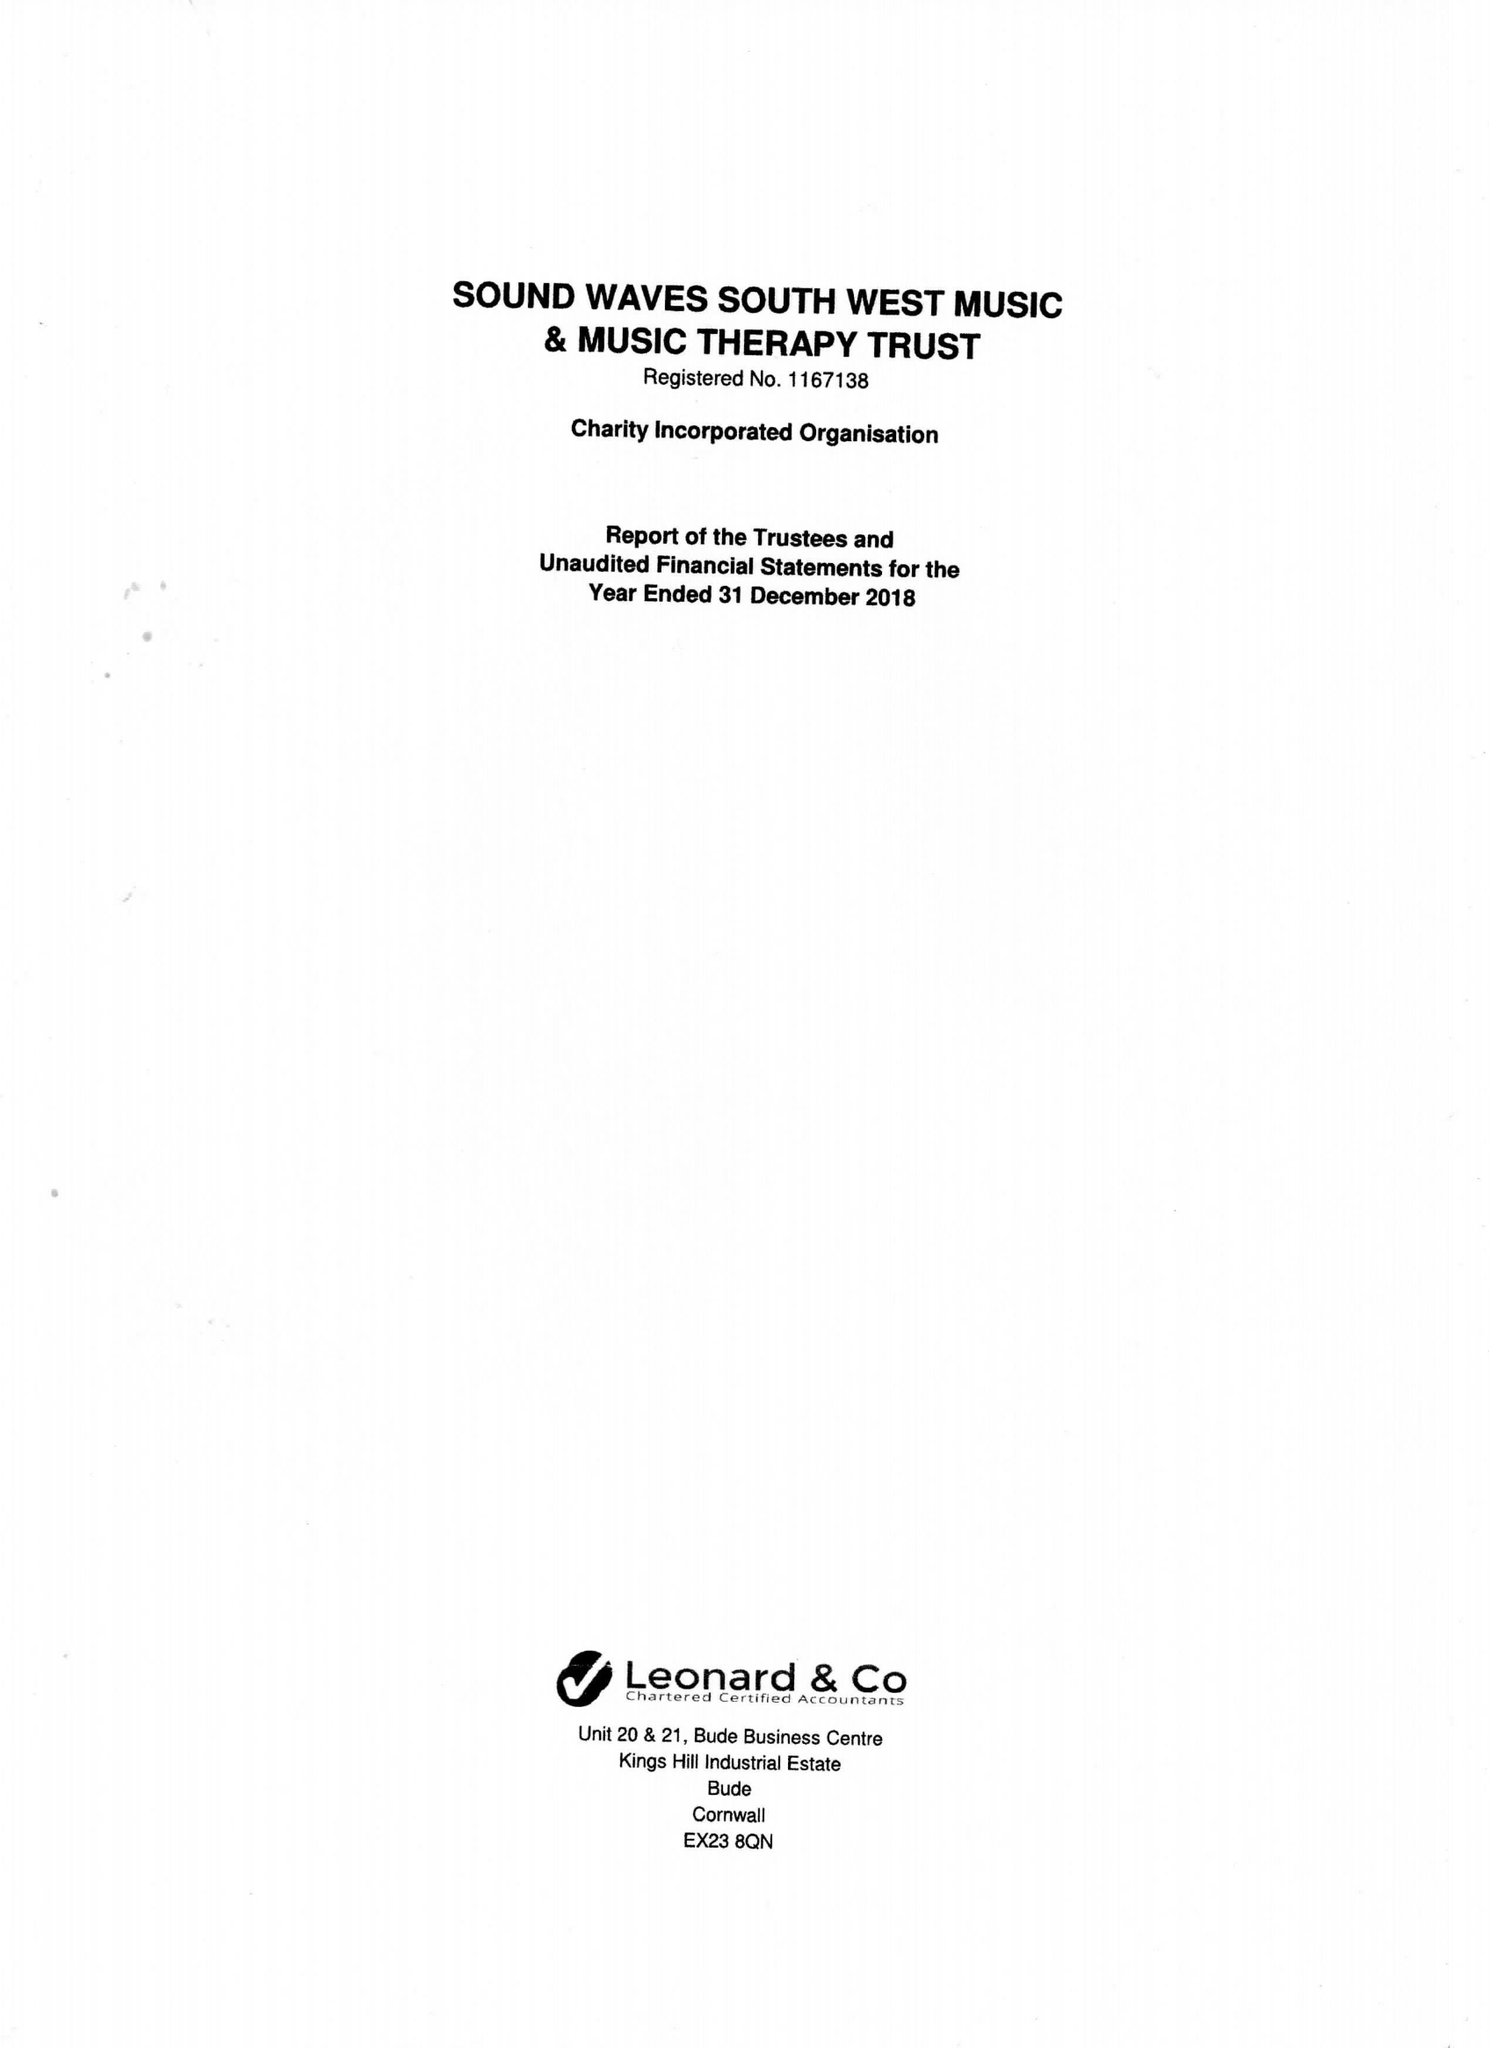What is the value for the income_annually_in_british_pounds?
Answer the question using a single word or phrase. 21554.00 